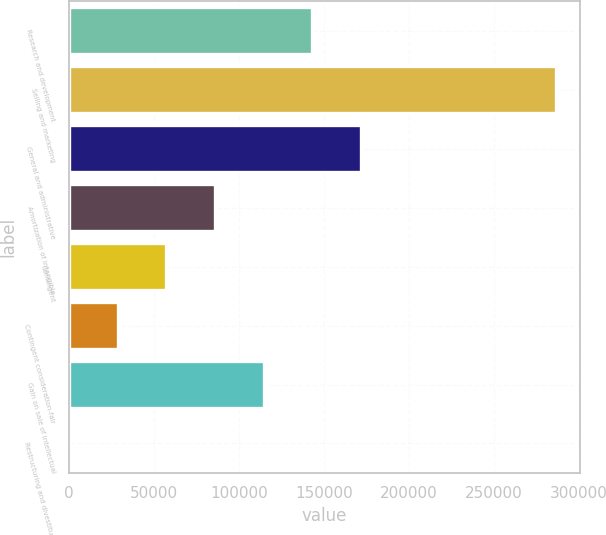<chart> <loc_0><loc_0><loc_500><loc_500><bar_chart><fcel>Research and development<fcel>Selling and marketing<fcel>General and administrative<fcel>Amortization of intangible<fcel>Contingent<fcel>Contingent consideration-fair<fcel>Gain on sale of intellectual<fcel>Restructuring and divestiture<nl><fcel>143400<fcel>286730<fcel>172066<fcel>86068.7<fcel>57402.8<fcel>28736.9<fcel>114735<fcel>71<nl></chart> 